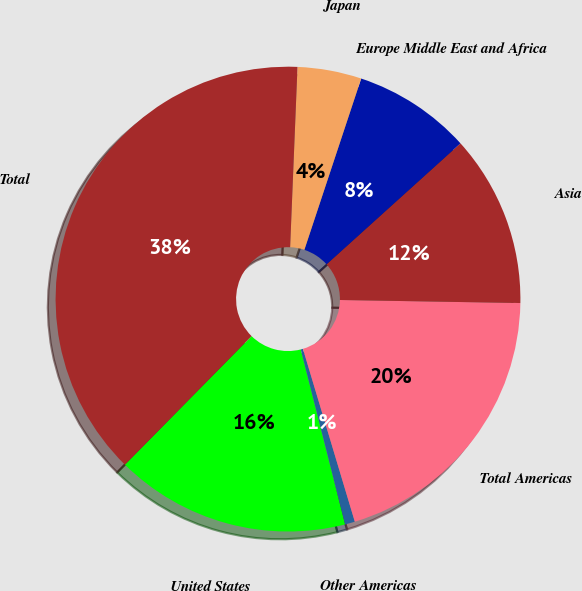Convert chart to OTSL. <chart><loc_0><loc_0><loc_500><loc_500><pie_chart><fcel>United States<fcel>Other Americas<fcel>Total Americas<fcel>Asia<fcel>Europe Middle East and Africa<fcel>Japan<fcel>Total<nl><fcel>16.33%<fcel>0.69%<fcel>20.09%<fcel>11.96%<fcel>8.21%<fcel>4.45%<fcel>38.27%<nl></chart> 